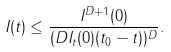Convert formula to latex. <formula><loc_0><loc_0><loc_500><loc_500>I ( t ) \leq \frac { I ^ { D + 1 } ( 0 ) } { ( D I _ { t } ( 0 ) ( t _ { 0 } - t ) ) ^ { D } } .</formula> 